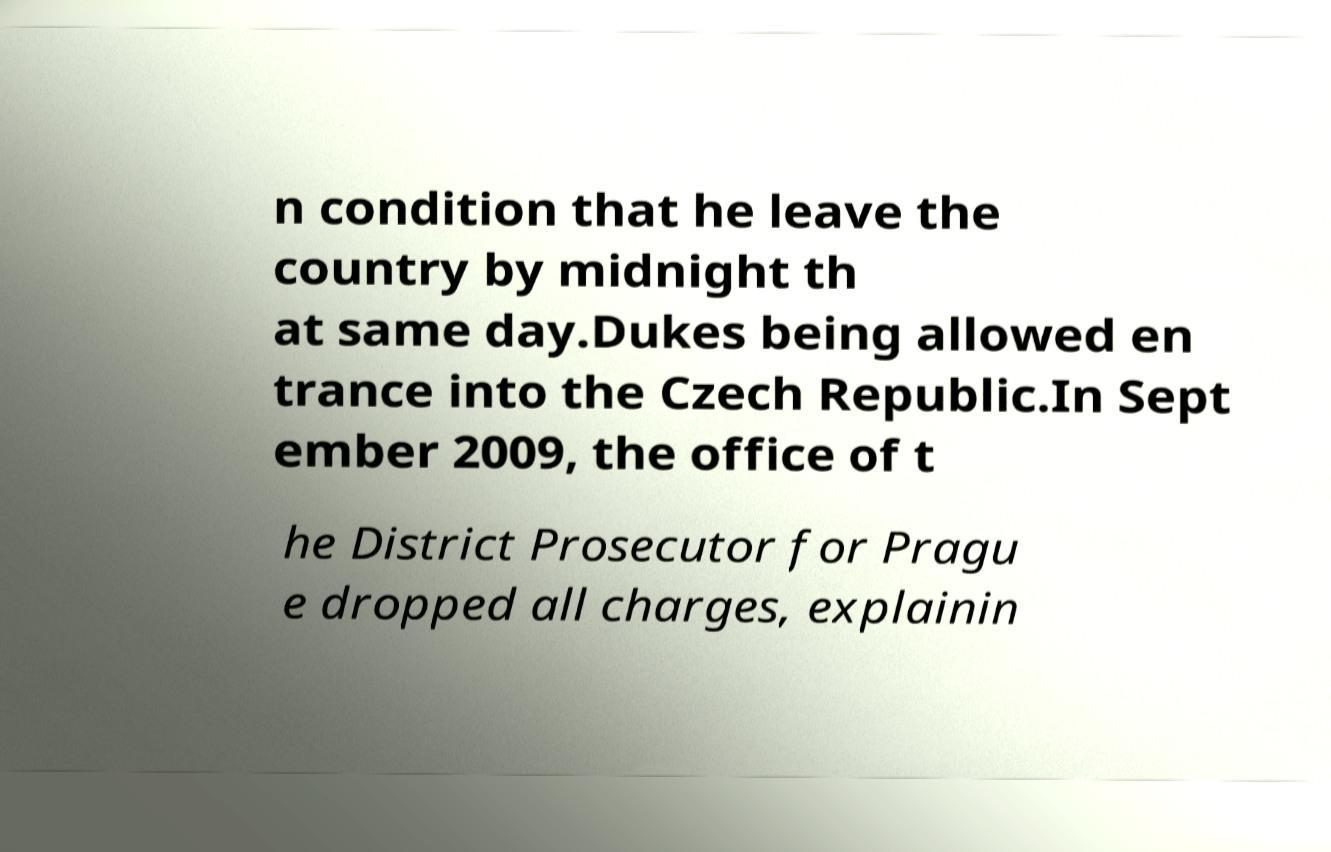Can you accurately transcribe the text from the provided image for me? n condition that he leave the country by midnight th at same day.Dukes being allowed en trance into the Czech Republic.In Sept ember 2009, the office of t he District Prosecutor for Pragu e dropped all charges, explainin 